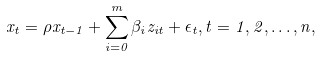Convert formula to latex. <formula><loc_0><loc_0><loc_500><loc_500>x _ { t } = \rho x _ { t - 1 } + \sum _ { i = 0 } ^ { m } \beta _ { i } z _ { i t } + \epsilon _ { t } , t = 1 , 2 , \dots , n ,</formula> 